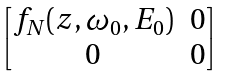Convert formula to latex. <formula><loc_0><loc_0><loc_500><loc_500>\begin{bmatrix} f _ { N } ( z , \omega _ { 0 } , E _ { 0 } ) & 0 \\ 0 & 0 \end{bmatrix}</formula> 